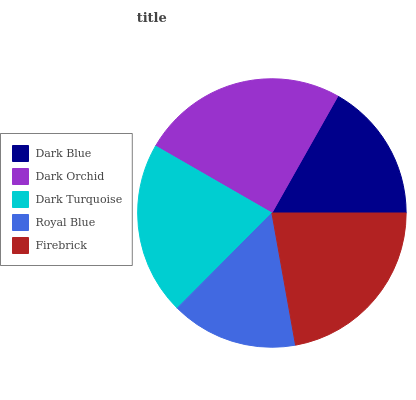Is Royal Blue the minimum?
Answer yes or no. Yes. Is Dark Orchid the maximum?
Answer yes or no. Yes. Is Dark Turquoise the minimum?
Answer yes or no. No. Is Dark Turquoise the maximum?
Answer yes or no. No. Is Dark Orchid greater than Dark Turquoise?
Answer yes or no. Yes. Is Dark Turquoise less than Dark Orchid?
Answer yes or no. Yes. Is Dark Turquoise greater than Dark Orchid?
Answer yes or no. No. Is Dark Orchid less than Dark Turquoise?
Answer yes or no. No. Is Dark Turquoise the high median?
Answer yes or no. Yes. Is Dark Turquoise the low median?
Answer yes or no. Yes. Is Dark Blue the high median?
Answer yes or no. No. Is Dark Orchid the low median?
Answer yes or no. No. 